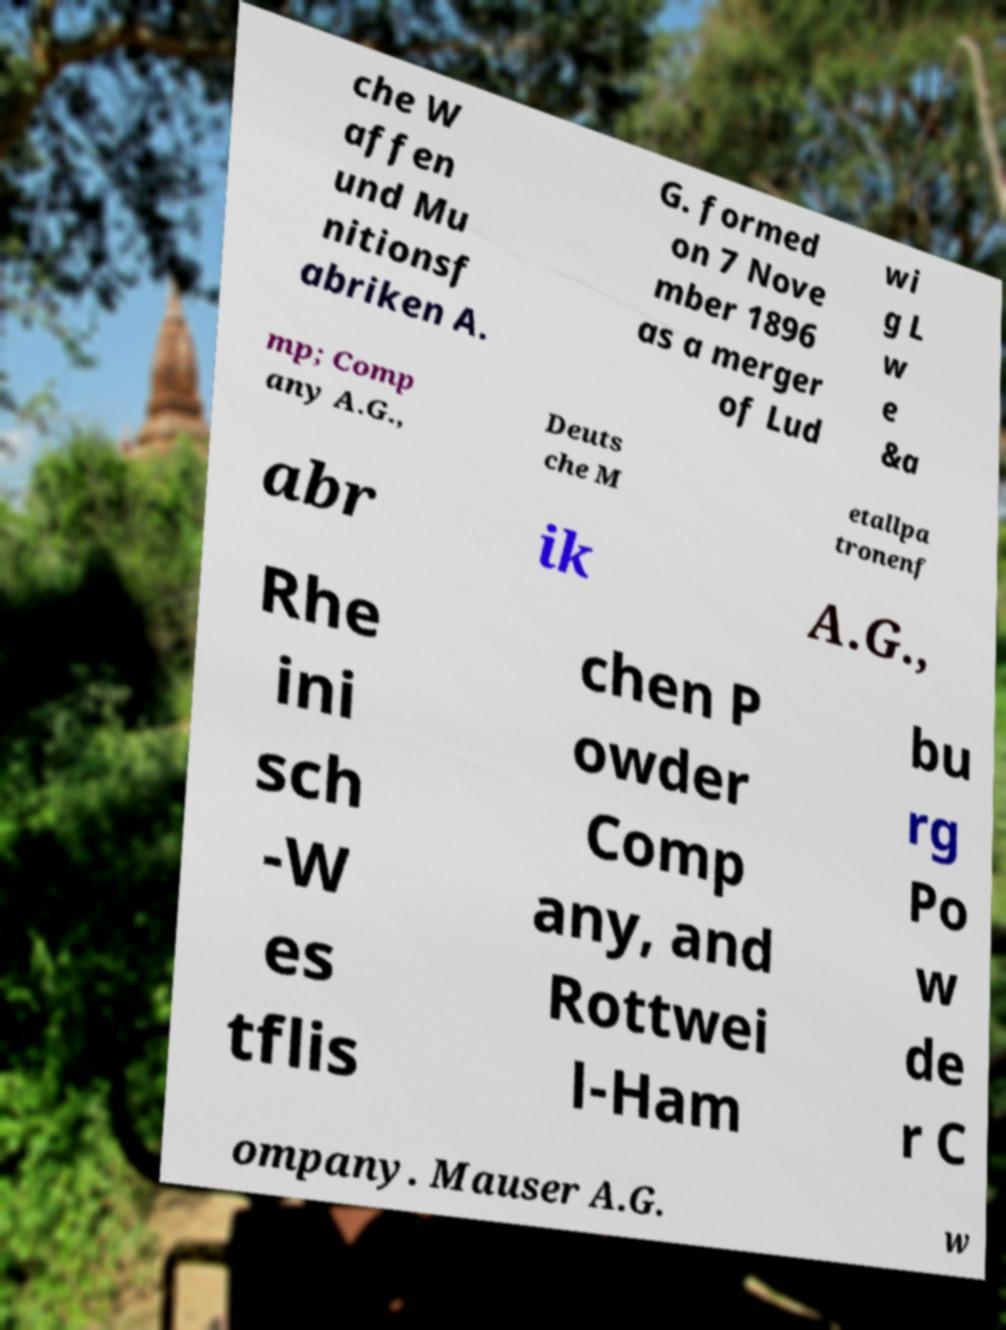For documentation purposes, I need the text within this image transcribed. Could you provide that? che W affen und Mu nitionsf abriken A. G. formed on 7 Nove mber 1896 as a merger of Lud wi g L w e &a mp; Comp any A.G., Deuts che M etallpa tronenf abr ik A.G., Rhe ini sch -W es tflis chen P owder Comp any, and Rottwei l-Ham bu rg Po w de r C ompany. Mauser A.G. w 